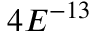<formula> <loc_0><loc_0><loc_500><loc_500>4 E ^ { - 1 3 }</formula> 